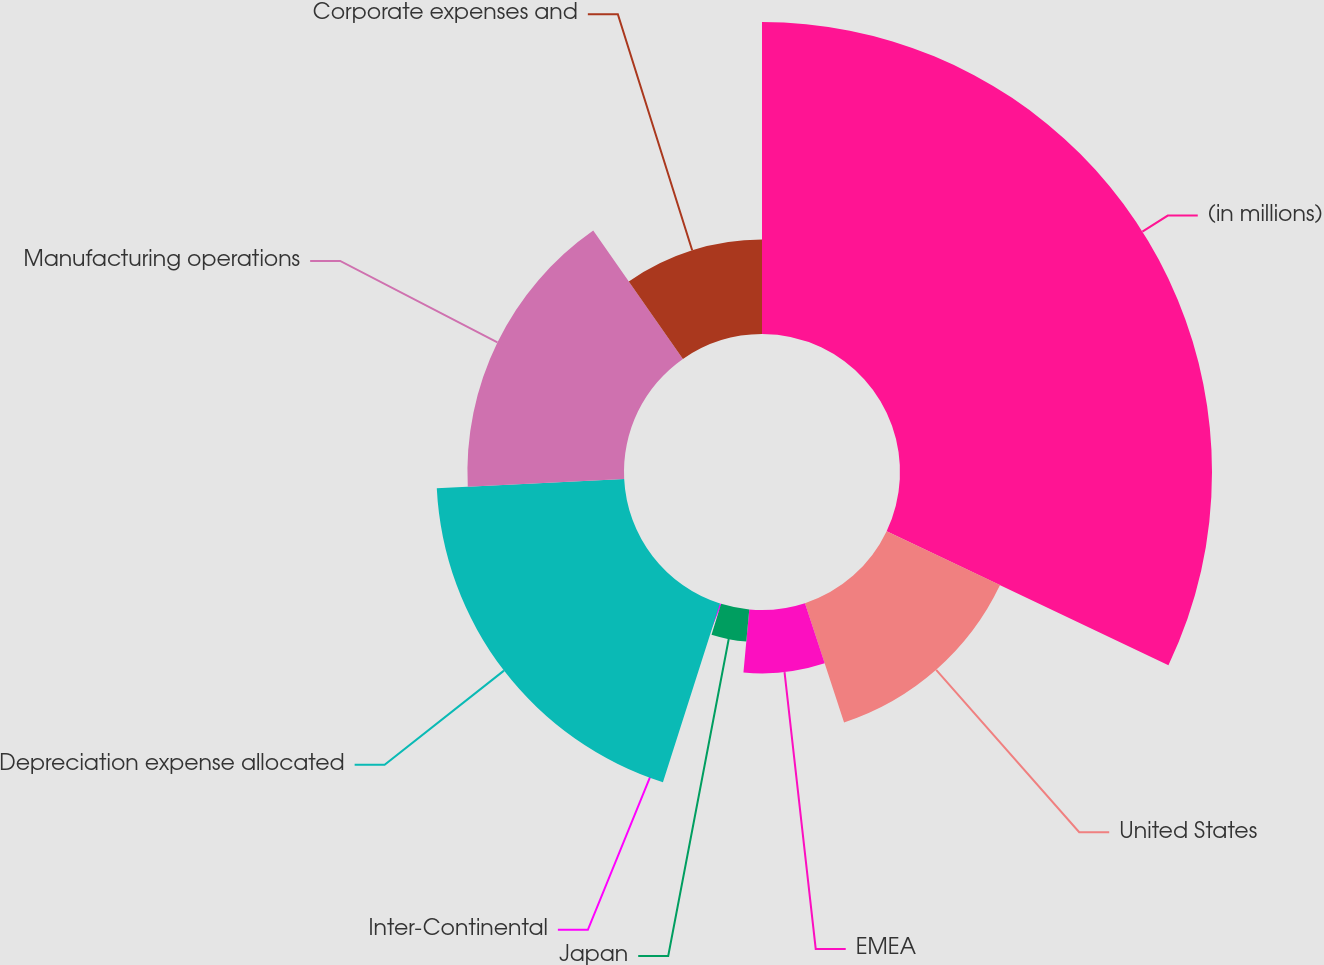<chart> <loc_0><loc_0><loc_500><loc_500><pie_chart><fcel>(in millions)<fcel>United States<fcel>EMEA<fcel>Japan<fcel>Inter-Continental<fcel>Depreciation expense allocated<fcel>Manufacturing operations<fcel>Corporate expenses and<nl><fcel>32.06%<fcel>12.9%<fcel>6.51%<fcel>3.32%<fcel>0.13%<fcel>19.28%<fcel>16.09%<fcel>9.71%<nl></chart> 